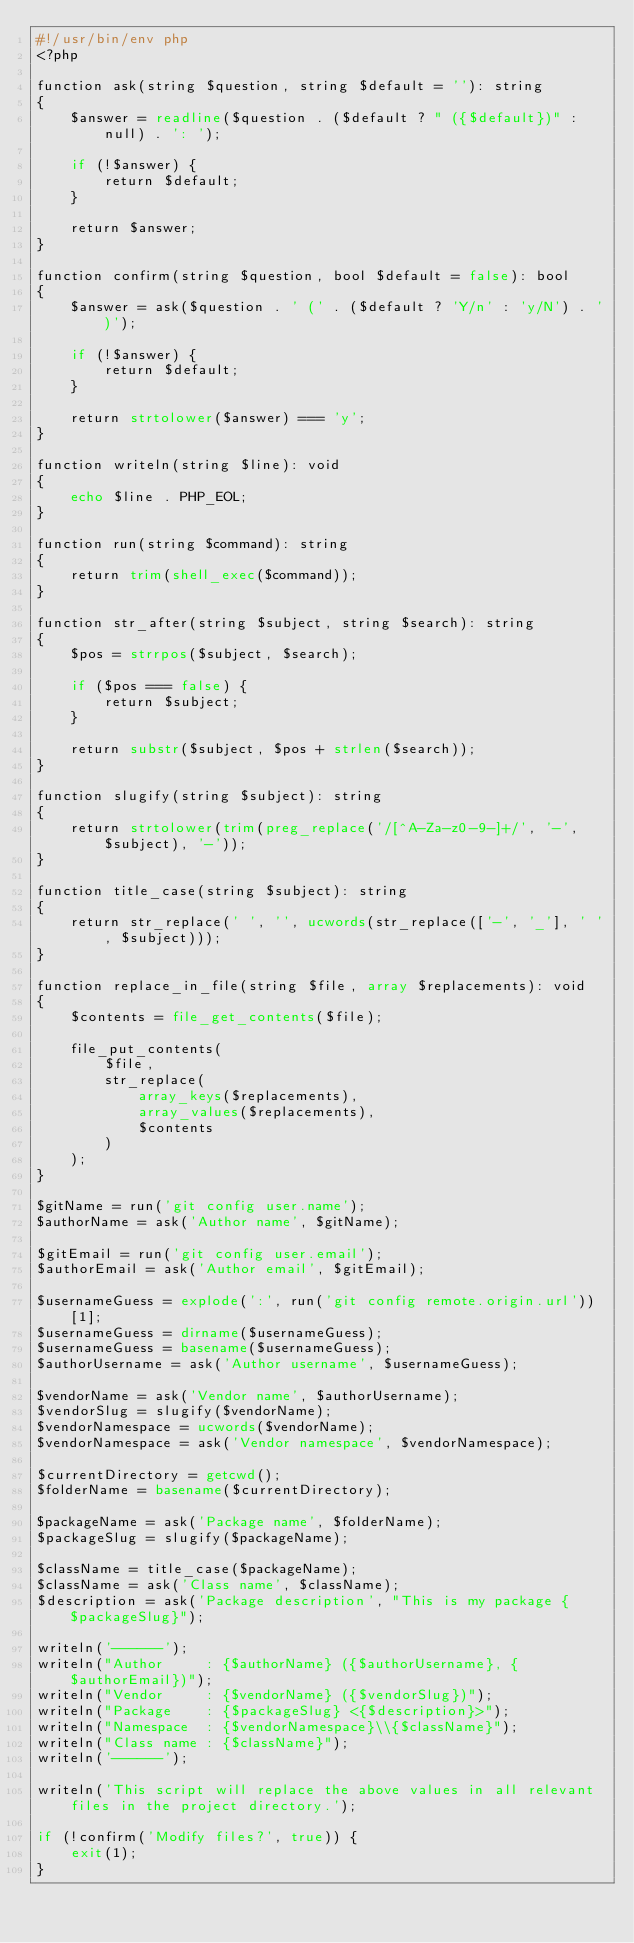<code> <loc_0><loc_0><loc_500><loc_500><_PHP_>#!/usr/bin/env php
<?php

function ask(string $question, string $default = ''): string
{
    $answer = readline($question . ($default ? " ({$default})" : null) . ': ');

    if (!$answer) {
        return $default;
    }

    return $answer;
}

function confirm(string $question, bool $default = false): bool
{
    $answer = ask($question . ' (' . ($default ? 'Y/n' : 'y/N') . ')');

    if (!$answer) {
        return $default;
    }

    return strtolower($answer) === 'y';
}

function writeln(string $line): void
{
    echo $line . PHP_EOL;
}

function run(string $command): string
{
    return trim(shell_exec($command));
}

function str_after(string $subject, string $search): string
{
    $pos = strrpos($subject, $search);

    if ($pos === false) {
        return $subject;
    }

    return substr($subject, $pos + strlen($search));
}

function slugify(string $subject): string
{
    return strtolower(trim(preg_replace('/[^A-Za-z0-9-]+/', '-', $subject), '-'));
}

function title_case(string $subject): string
{
    return str_replace(' ', '', ucwords(str_replace(['-', '_'], ' ', $subject)));
}

function replace_in_file(string $file, array $replacements): void
{
    $contents = file_get_contents($file);

    file_put_contents(
        $file,
        str_replace(
            array_keys($replacements),
            array_values($replacements),
            $contents
        )
    );
}

$gitName = run('git config user.name');
$authorName = ask('Author name', $gitName);

$gitEmail = run('git config user.email');
$authorEmail = ask('Author email', $gitEmail);

$usernameGuess = explode(':', run('git config remote.origin.url'))[1];
$usernameGuess = dirname($usernameGuess);
$usernameGuess = basename($usernameGuess);
$authorUsername = ask('Author username', $usernameGuess);

$vendorName = ask('Vendor name', $authorUsername);
$vendorSlug = slugify($vendorName);
$vendorNamespace = ucwords($vendorName);
$vendorNamespace = ask('Vendor namespace', $vendorNamespace);

$currentDirectory = getcwd();
$folderName = basename($currentDirectory);

$packageName = ask('Package name', $folderName);
$packageSlug = slugify($packageName);

$className = title_case($packageName);
$className = ask('Class name', $className);
$description = ask('Package description', "This is my package {$packageSlug}");

writeln('------');
writeln("Author     : {$authorName} ({$authorUsername}, {$authorEmail})");
writeln("Vendor     : {$vendorName} ({$vendorSlug})");
writeln("Package    : {$packageSlug} <{$description}>");
writeln("Namespace  : {$vendorNamespace}\\{$className}");
writeln("Class name : {$className}");
writeln('------');

writeln('This script will replace the above values in all relevant files in the project directory.');

if (!confirm('Modify files?', true)) {
    exit(1);
}
</code> 